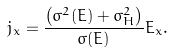Convert formula to latex. <formula><loc_0><loc_0><loc_500><loc_500>j _ { x } = \frac { \left ( \sigma ^ { 2 } ( E ) + \sigma _ { H } ^ { 2 } \right ) } { \sigma ( E ) } E _ { x } .</formula> 